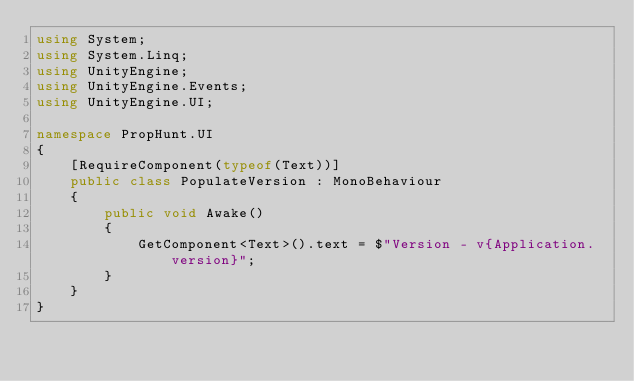<code> <loc_0><loc_0><loc_500><loc_500><_C#_>using System;
using System.Linq;
using UnityEngine;
using UnityEngine.Events;
using UnityEngine.UI;

namespace PropHunt.UI
{
    [RequireComponent(typeof(Text))]
    public class PopulateVersion : MonoBehaviour
    {
        public void Awake()
        {
            GetComponent<Text>().text = $"Version - v{Application.version}";
        }
    }
}</code> 